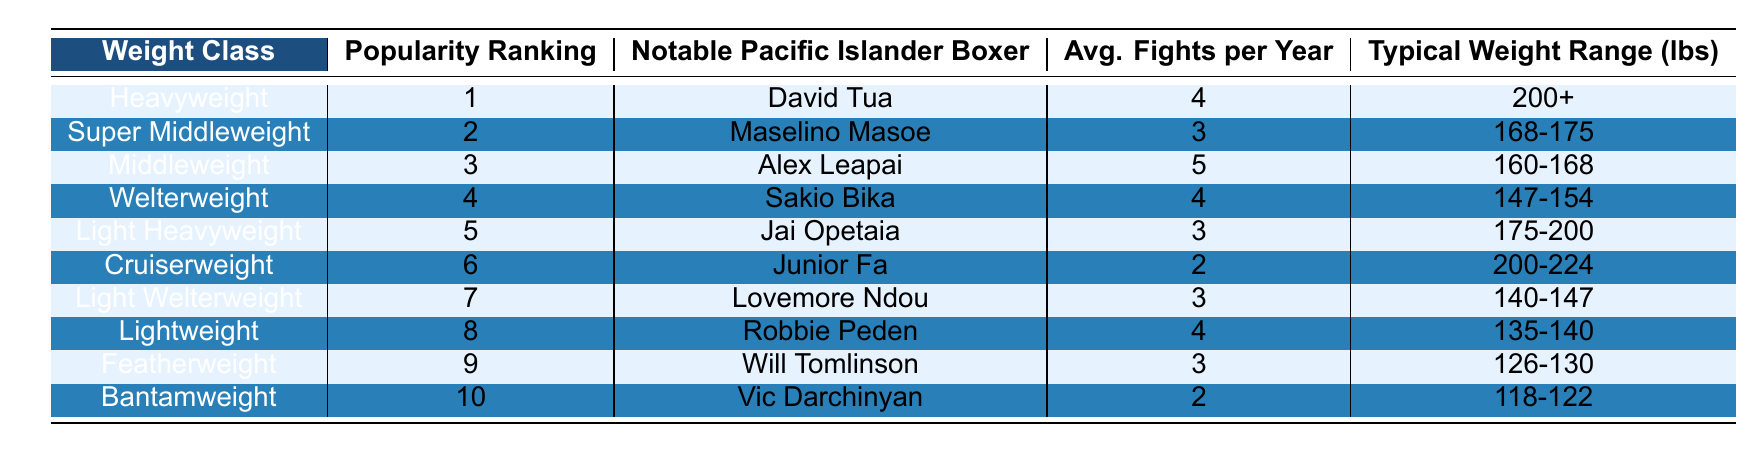What is the most popular boxing weight class among Pacific Islanders? The table shows that the Heavyweight class has the highest popularity ranking at 1, indicating that it is the most popular among Pacific Islanders.
Answer: Heavyweight Who is the notable Pacific Islander boxer in the Super Middleweight class? According to the table, the boxer listed for the Super Middleweight class is Maselino Masoe.
Answer: Maselino Masoe How many average fights per year does a Middleweight boxer have? The table indicates that Middleweight boxers have an average of 5 fights per year, as shown in the corresponding row for that weight class.
Answer: 5 Is there a boxing weight class where the average fights per year is 2? By examining the table, the Bantamweight and Cruiserweight classes both have an average of 2 fights per year, confirming that there are classes with this average.
Answer: Yes What is the typical weight range for a Lightweight boxer? The table specifies that the typical weight range for Lightweight boxers is between 135-140 lbs, as indicated in the row for that weight class.
Answer: 135-140 lbs Which boxing weight class has the lowest popularity ranking? Looking at the table, Bantamweight has the lowest popularity ranking at 10, making it the least popular weight class among Pacific Islanders.
Answer: Bantamweight What is the average number of fights per year for the top three most popular boxing weight classes combined? The top three classes are Heavyweight (4), Super Middleweight (3), and Middleweight (5). Adding them gives 4 + 3 + 5 = 12. Dividing by 3 (the number of classes) provides an average of 12/3 = 4.
Answer: 4 Are there any Pacific Islander boxers in the Light Heavyweight class? The table clearly shows that Jai Opetaia is a notable boxer in the Light Heavyweight class, confirming that there is representation in this weight class.
Answer: Yes What is the difference in average fights per year between Bantamweight and Middleweight? Bantamweight has an average of 2 fights per year, while Middleweight has 5. The difference is calculated by subtracting: 5 - 2 = 3.
Answer: 3 Which notable Pacific Islander boxer listed has the heaviest typical weight range? Reviewing the table, the Heavyweight class is the only one listed with a typical weight range of 200+ lbs, making David Tua the boxer with the heaviest weight representation.
Answer: David Tua 